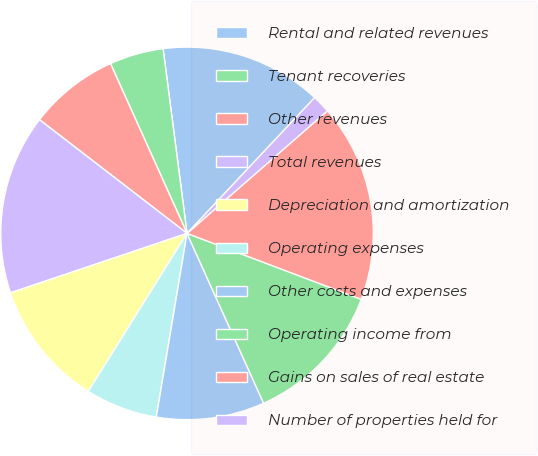<chart> <loc_0><loc_0><loc_500><loc_500><pie_chart><fcel>Rental and related revenues<fcel>Tenant recoveries<fcel>Other revenues<fcel>Total revenues<fcel>Depreciation and amortization<fcel>Operating expenses<fcel>Other costs and expenses<fcel>Operating income from<fcel>Gains on sales of real estate<fcel>Number of properties held for<nl><fcel>14.06%<fcel>4.69%<fcel>7.81%<fcel>15.62%<fcel>10.94%<fcel>6.25%<fcel>9.38%<fcel>12.5%<fcel>17.18%<fcel>1.57%<nl></chart> 